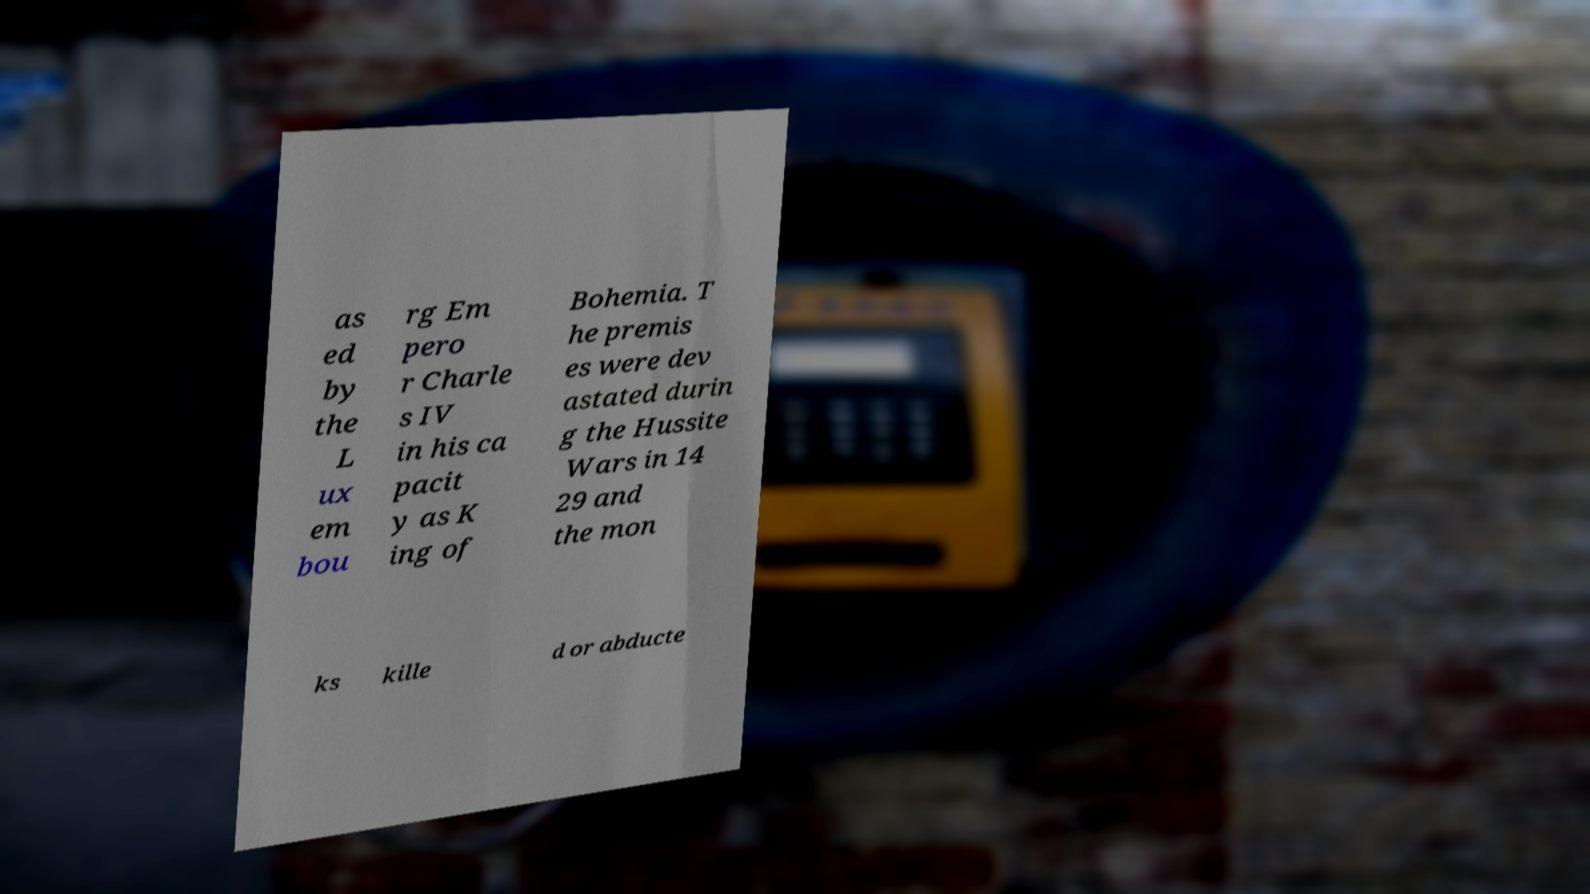There's text embedded in this image that I need extracted. Can you transcribe it verbatim? as ed by the L ux em bou rg Em pero r Charle s IV in his ca pacit y as K ing of Bohemia. T he premis es were dev astated durin g the Hussite Wars in 14 29 and the mon ks kille d or abducte 